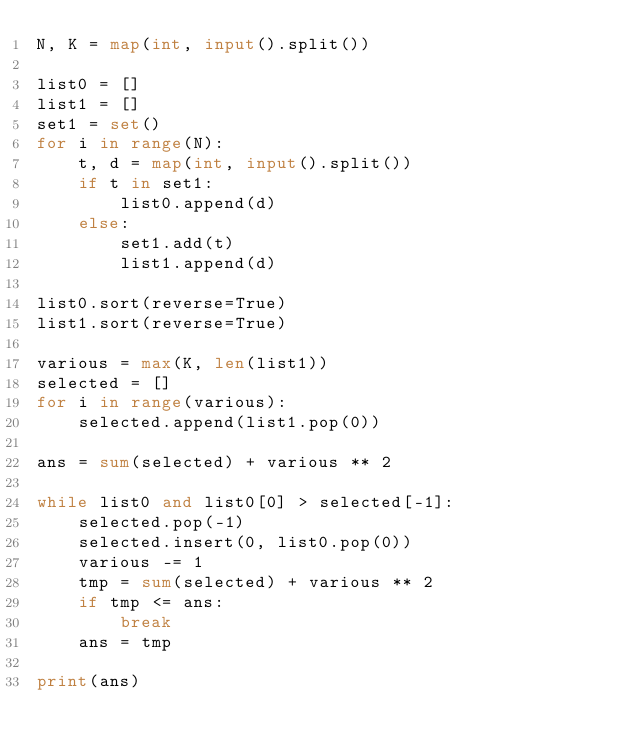<code> <loc_0><loc_0><loc_500><loc_500><_Python_>N, K = map(int, input().split())

list0 = []
list1 = []
set1 = set()
for i in range(N):
    t, d = map(int, input().split())
    if t in set1:
        list0.append(d)
    else:
        set1.add(t)
        list1.append(d)

list0.sort(reverse=True)
list1.sort(reverse=True)

various = max(K, len(list1))
selected = []
for i in range(various):
    selected.append(list1.pop(0))

ans = sum(selected) + various ** 2

while list0 and list0[0] > selected[-1]:
    selected.pop(-1)
    selected.insert(0, list0.pop(0))
    various -= 1
    tmp = sum(selected) + various ** 2
    if tmp <= ans:
        break
    ans = tmp

print(ans)
</code> 